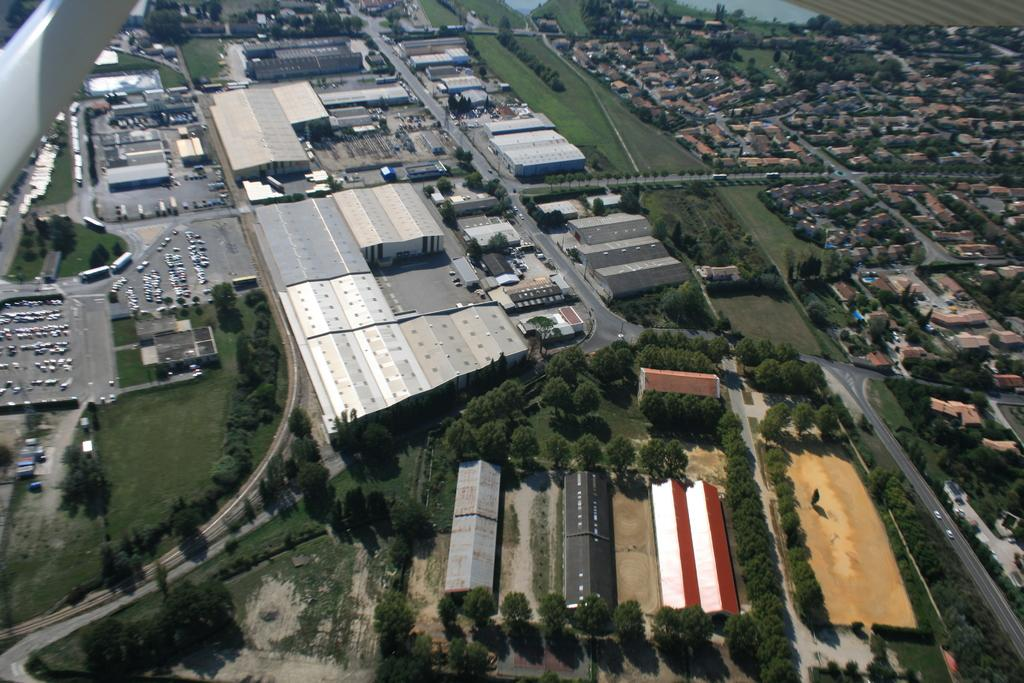What type of structures can be seen in the image? There are buildings in the image. What other natural elements are present in the image? There are trees in the image. What man-made objects can be seen in the image? There are vehicles in the image. How many pies are being served at the rest stop in the image? There is no rest stop or pies present in the image. What type of pig can be seen interacting with the vehicles in the image? There is no pig present in the image; only buildings, trees, and vehicles are visible. 